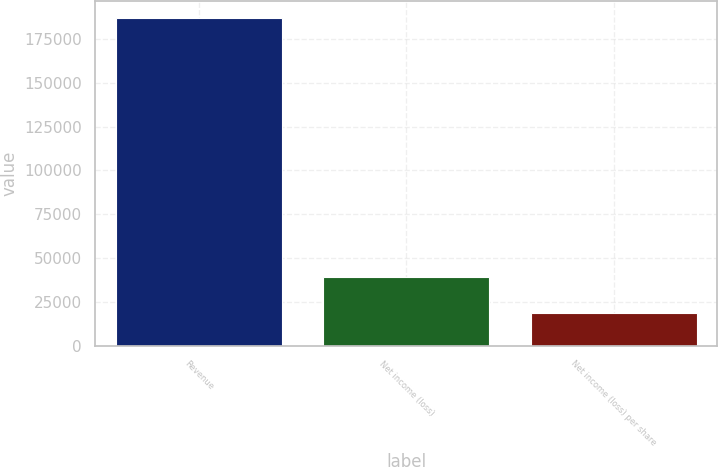Convert chart to OTSL. <chart><loc_0><loc_0><loc_500><loc_500><bar_chart><fcel>Revenue<fcel>Net income (loss)<fcel>Net income (loss) per share<nl><fcel>187103<fcel>38957<fcel>18710.9<nl></chart> 